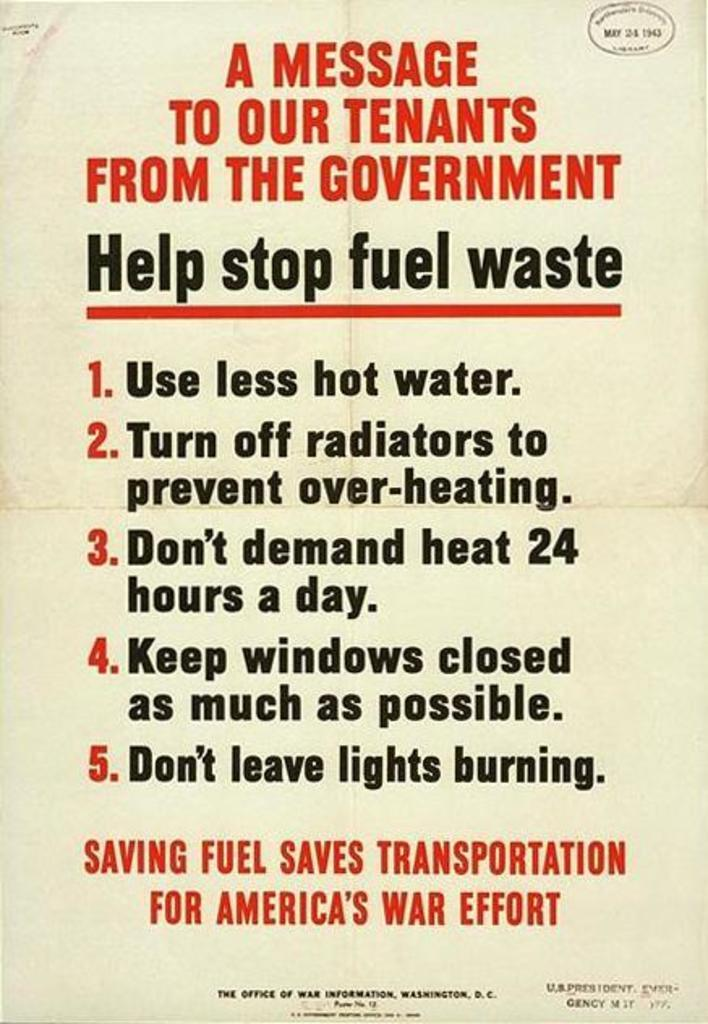<image>
Create a compact narrative representing the image presented. A poster suggesting how to Help Stop Fuel Waste. 